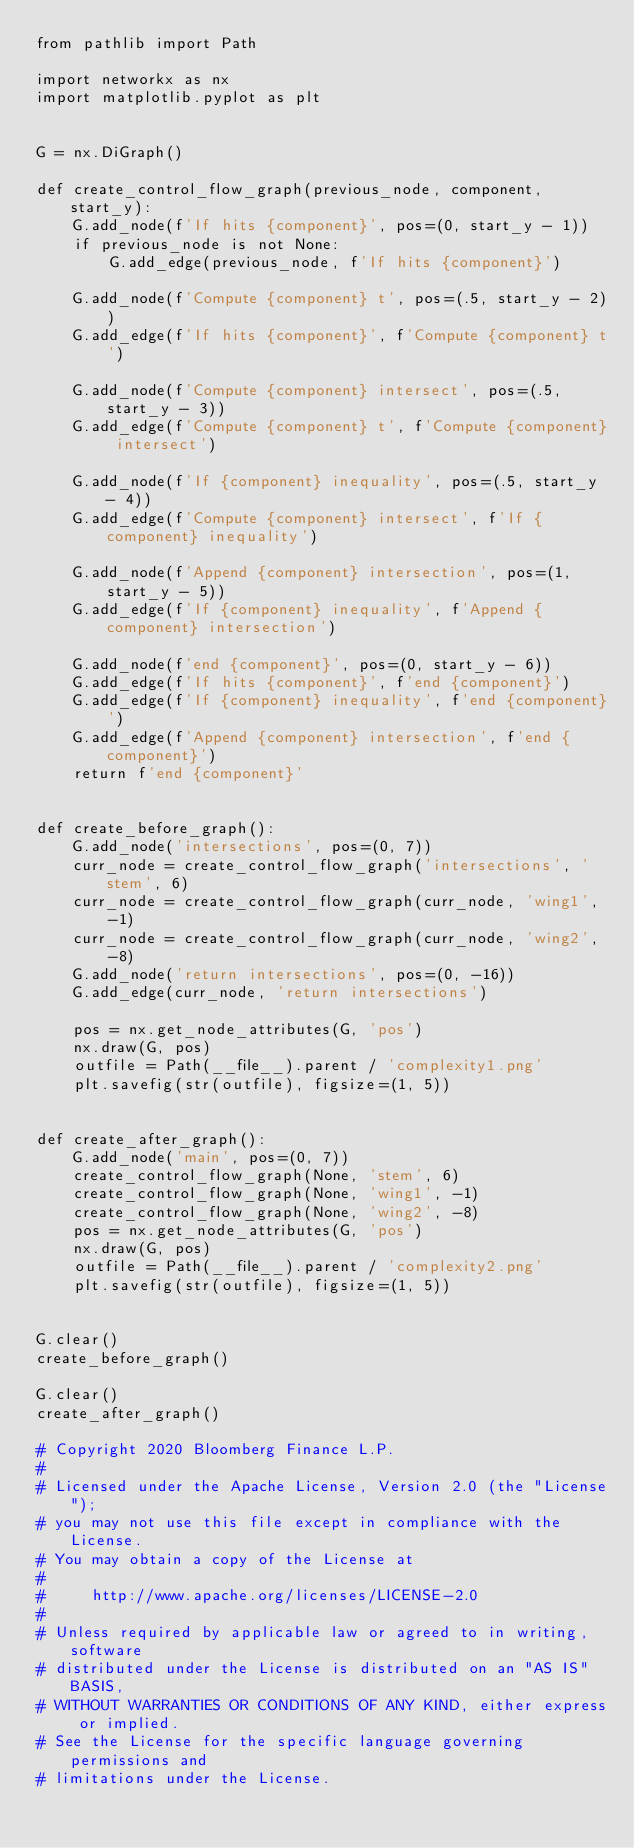Convert code to text. <code><loc_0><loc_0><loc_500><loc_500><_Python_>from pathlib import Path

import networkx as nx
import matplotlib.pyplot as plt


G = nx.DiGraph()

def create_control_flow_graph(previous_node, component, start_y):
    G.add_node(f'If hits {component}', pos=(0, start_y - 1))
    if previous_node is not None:
        G.add_edge(previous_node, f'If hits {component}')

    G.add_node(f'Compute {component} t', pos=(.5, start_y - 2))
    G.add_edge(f'If hits {component}', f'Compute {component} t')

    G.add_node(f'Compute {component} intersect', pos=(.5, start_y - 3))
    G.add_edge(f'Compute {component} t', f'Compute {component} intersect')

    G.add_node(f'If {component} inequality', pos=(.5, start_y - 4))
    G.add_edge(f'Compute {component} intersect', f'If {component} inequality')

    G.add_node(f'Append {component} intersection', pos=(1, start_y - 5))
    G.add_edge(f'If {component} inequality', f'Append {component} intersection')

    G.add_node(f'end {component}', pos=(0, start_y - 6))
    G.add_edge(f'If hits {component}', f'end {component}')
    G.add_edge(f'If {component} inequality', f'end {component}')
    G.add_edge(f'Append {component} intersection', f'end {component}')
    return f'end {component}'


def create_before_graph():
    G.add_node('intersections', pos=(0, 7))
    curr_node = create_control_flow_graph('intersections', 'stem', 6)
    curr_node = create_control_flow_graph(curr_node, 'wing1', -1)
    curr_node = create_control_flow_graph(curr_node, 'wing2', -8)
    G.add_node('return intersections', pos=(0, -16))
    G.add_edge(curr_node, 'return intersections')

    pos = nx.get_node_attributes(G, 'pos')
    nx.draw(G, pos)
    outfile = Path(__file__).parent / 'complexity1.png'
    plt.savefig(str(outfile), figsize=(1, 5))


def create_after_graph():
    G.add_node('main', pos=(0, 7))
    create_control_flow_graph(None, 'stem', 6)
    create_control_flow_graph(None, 'wing1', -1)
    create_control_flow_graph(None, 'wing2', -8)
    pos = nx.get_node_attributes(G, 'pos')
    nx.draw(G, pos)
    outfile = Path(__file__).parent / 'complexity2.png'
    plt.savefig(str(outfile), figsize=(1, 5))


G.clear()
create_before_graph()

G.clear()
create_after_graph()

# Copyright 2020 Bloomberg Finance L.P.
#
# Licensed under the Apache License, Version 2.0 (the "License");
# you may not use this file except in compliance with the License.
# You may obtain a copy of the License at
#
#     http://www.apache.org/licenses/LICENSE-2.0
#
# Unless required by applicable law or agreed to in writing, software
# distributed under the License is distributed on an "AS IS" BASIS,
# WITHOUT WARRANTIES OR CONDITIONS OF ANY KIND, either express or implied.
# See the License for the specific language governing permissions and
# limitations under the License.
</code> 